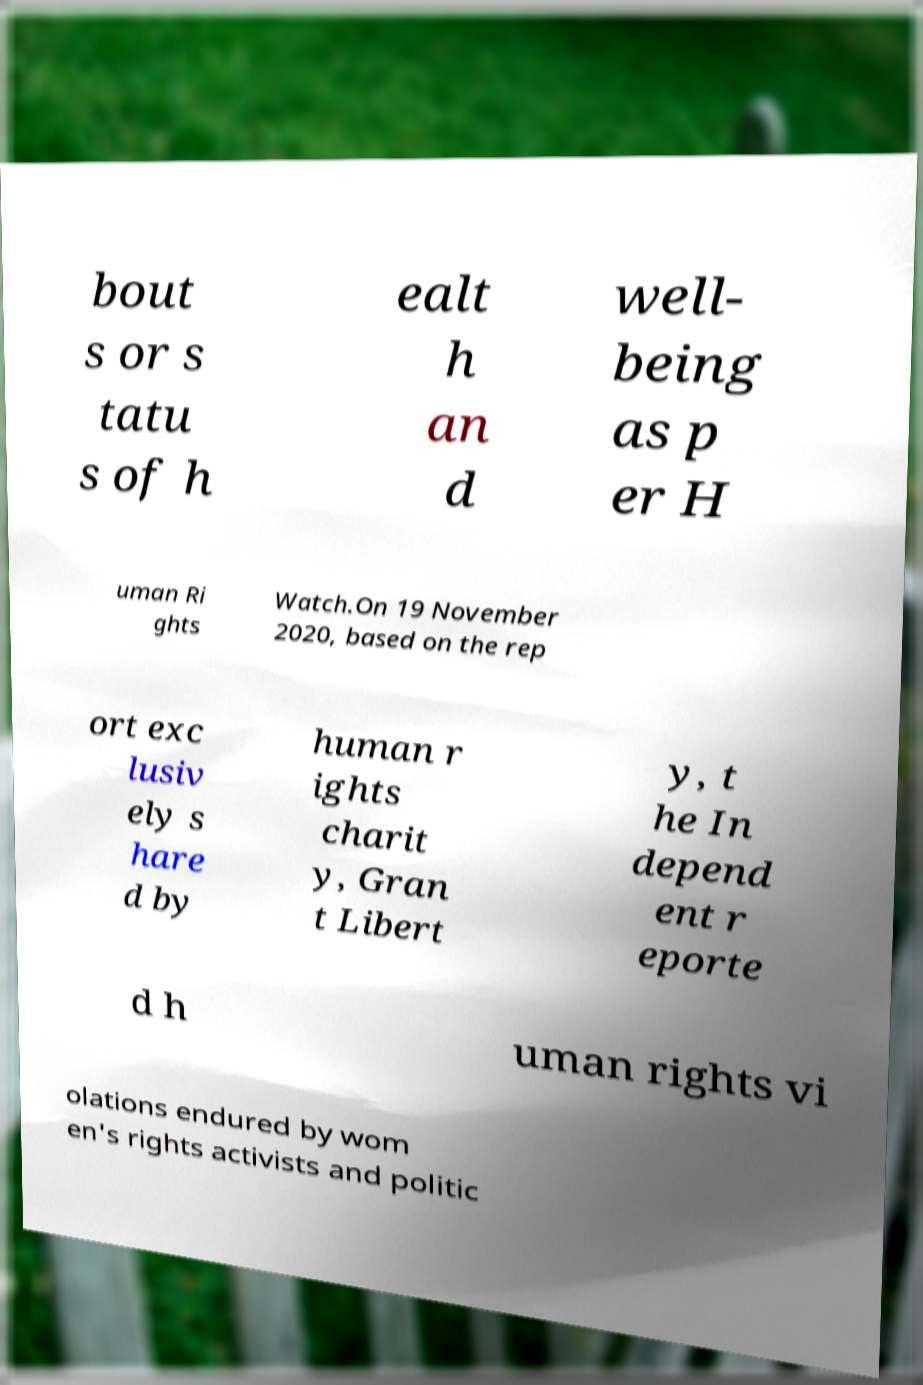Please identify and transcribe the text found in this image. bout s or s tatu s of h ealt h an d well- being as p er H uman Ri ghts Watch.On 19 November 2020, based on the rep ort exc lusiv ely s hare d by human r ights charit y, Gran t Libert y, t he In depend ent r eporte d h uman rights vi olations endured by wom en's rights activists and politic 